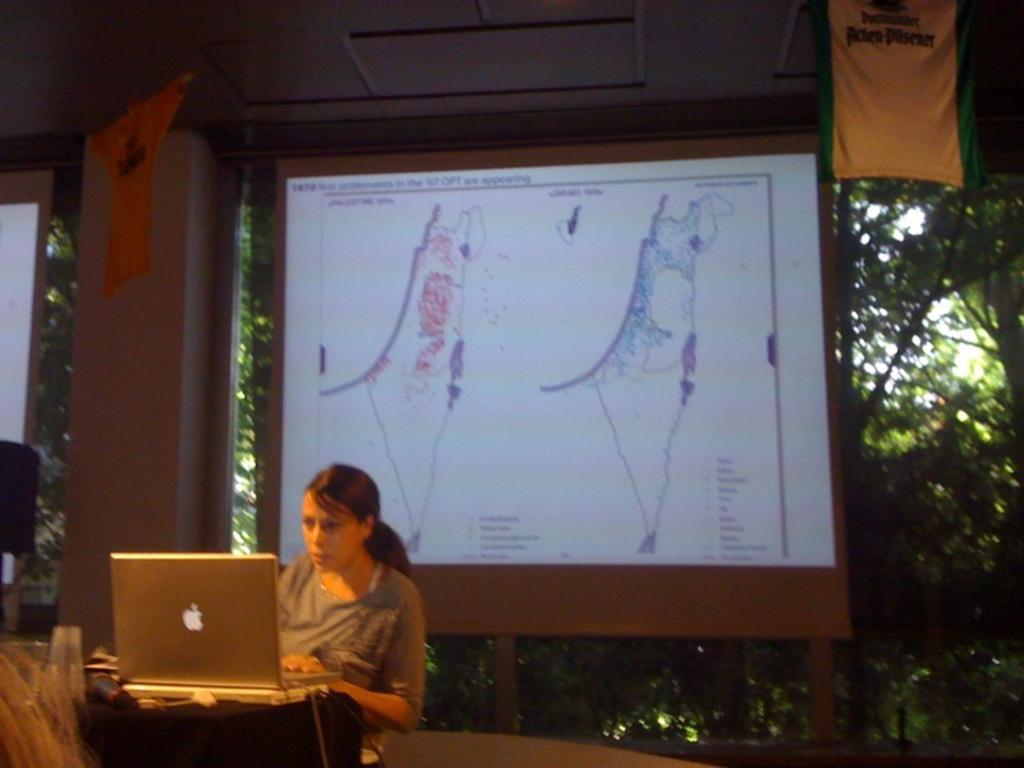How would you summarize this image in a sentence or two? In this image there is a person sitting, there is laptop on the table, there is a microphone on the table, there is a glass on the table, there is a screen, there are flags, there is a pillar, a screen is truncated towards the left of the image, there is an object is truncated towards the left of the image, there is a roof, there are trees. 